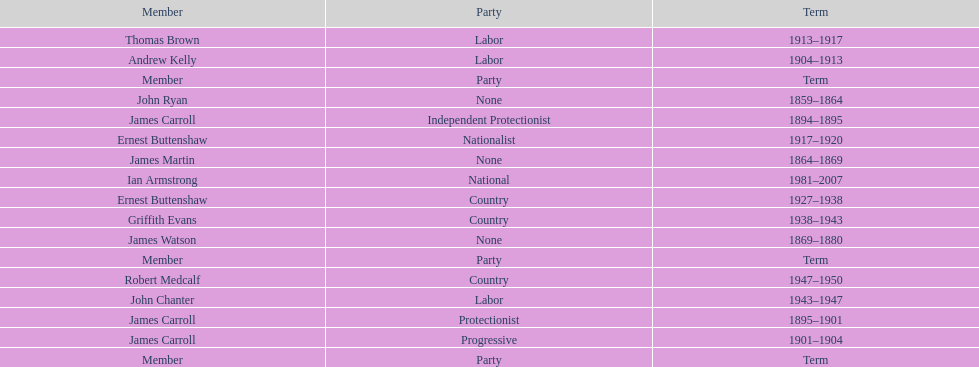Which member of the second incarnation of the lachlan was also a nationalist? Ernest Buttenshaw. 